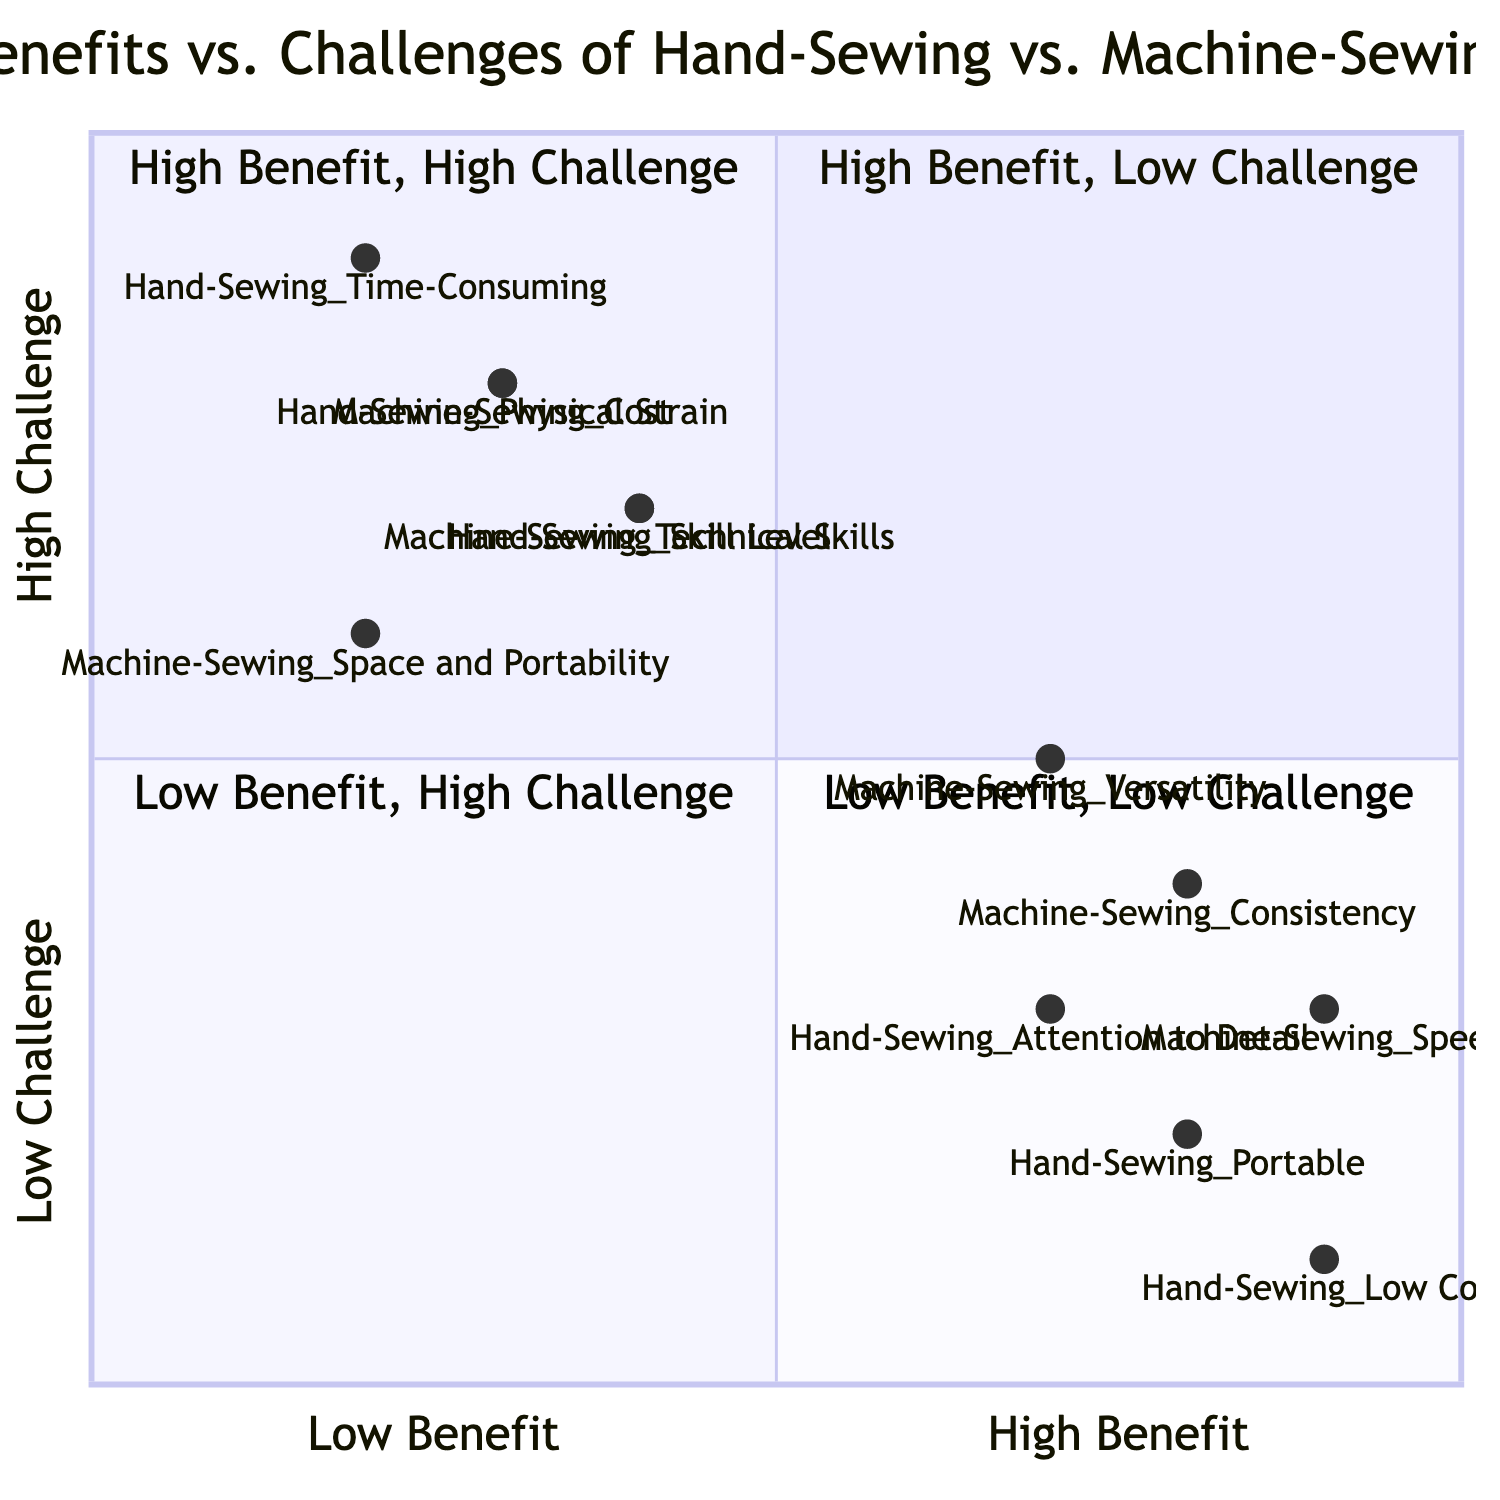What is the benefit of hand-sewing that has the highest score? Referring to the diagram, I check the coordinates of the benefits of hand-sewing. The benefit "Low Cost" has the highest benefit value at 0.9.
Answer: Low Cost Which hand-sewing challenge is ranked the worst in benefit? To determine the worst benefit ranking among hand-sewing challenges, I look for the challenge with the lowest benefit score. "Time-Consuming" has the lowest benefit value at 0.2.
Answer: Time-Consuming What is the benefit associated with machine-sewing that is closest to the high benefit threshold? I examine the benefits of machine-sewing and locate the one with a score closest to 1. "Speed" has a benefit score of 0.9, the highest among machine-sewing benefits.
Answer: Speed How many nodes represent challenges in machine-sewing? By counting the entries under machine-sewing challenges in the diagram, I find that there are three listed nodes: "Cost," "Technical Skills," and "Space and Portability."
Answer: 3 Which hand-sewing benefit is the least challenging? I check the challenges associated with each hand-sewing benefit. "Low Cost" has the lowest challenge score of 0.1, making it the least challenging benefit in hand-sewing.
Answer: Low Cost What is the positioning of the "Versatility" benefit in terms of benefit and challenge scores? I analyze "Versatility," which is part of machine-sewing. Its scores are 0.7 for benefit and 0.5 for challenge, placing it in the second quadrant where benefits are higher than challenges, but not the highest.
Answer: [0.7, 0.5] Which quadrant contains the "Technical Skills" challenge? Upon examining the score for "Technical Skills," which is 0.4 for benefit and 0.7 for challenge, it falls in the third quadrant since it has low benefit and high challenge.
Answer: Quadrant 3 What benefit does hand-sewing offer that is described as portable? Reviewing the hand-sewing benefits, I find that the specific benefit is labeled "Portable" with a score of 0.8.
Answer: Portable Which of the machine-sewing challenges has the lowest benefit value? I compare the benefit scores of the machine-sewing challenges. "Space and Portability," with a benefit value of 0.2, has the lowest of all machine-sewing challenges.
Answer: Space and Portability 